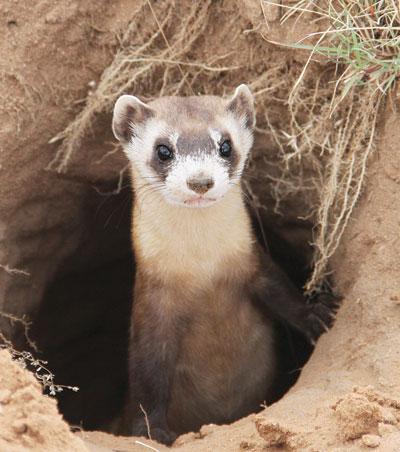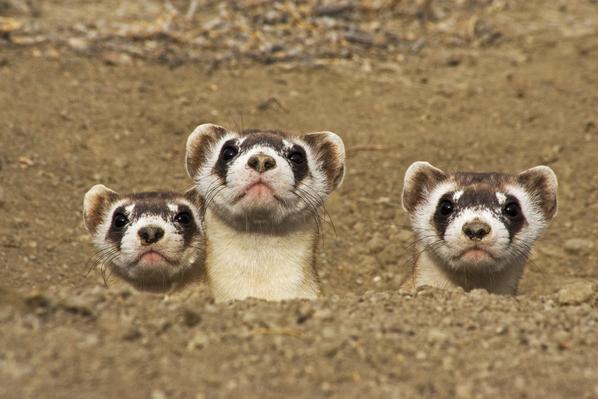The first image is the image on the left, the second image is the image on the right. For the images displayed, is the sentence "A total of four ferrets are shown, all sticking their heads up above the surface of the ground." factually correct? Answer yes or no. Yes. The first image is the image on the left, the second image is the image on the right. Examine the images to the left and right. Is the description "There are exactly 4 animals." accurate? Answer yes or no. Yes. 